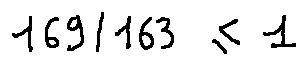<formula> <loc_0><loc_0><loc_500><loc_500>1 6 9 / 1 6 3 \leq 1</formula> 